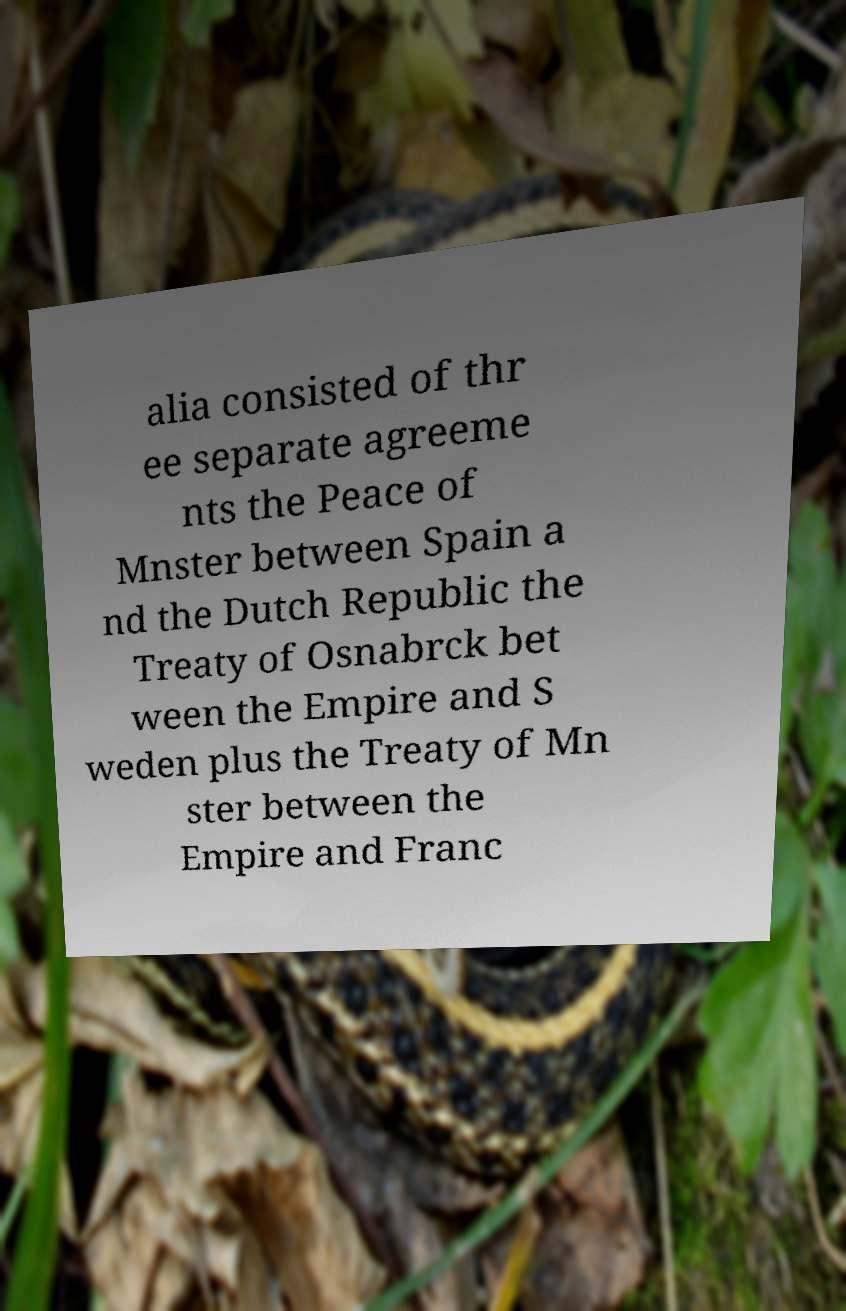Could you extract and type out the text from this image? alia consisted of thr ee separate agreeme nts the Peace of Mnster between Spain a nd the Dutch Republic the Treaty of Osnabrck bet ween the Empire and S weden plus the Treaty of Mn ster between the Empire and Franc 